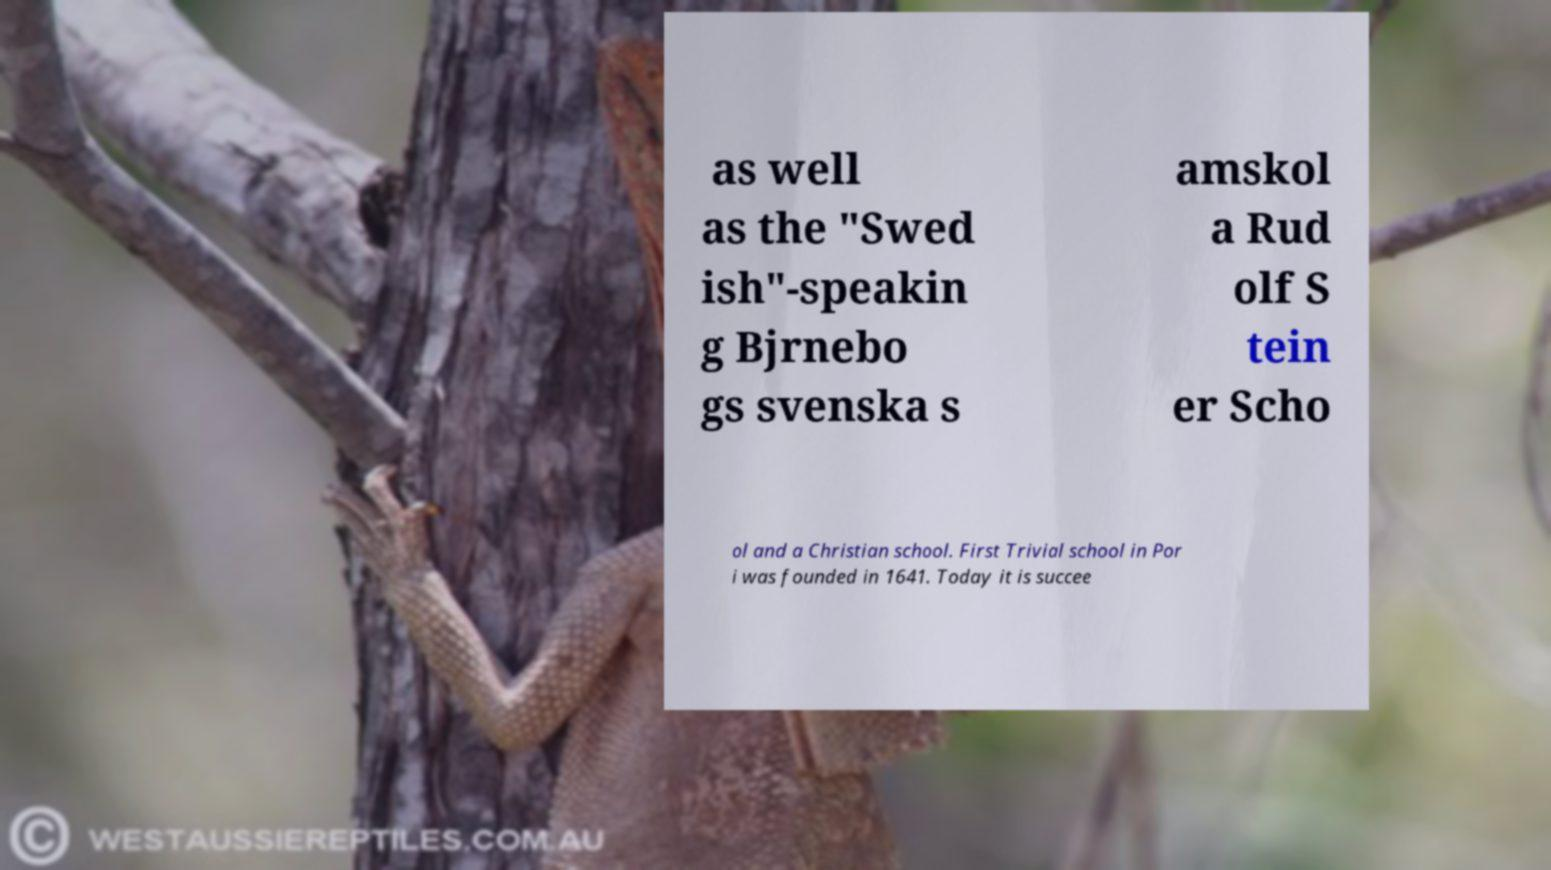For documentation purposes, I need the text within this image transcribed. Could you provide that? as well as the "Swed ish"-speakin g Bjrnebo gs svenska s amskol a Rud olf S tein er Scho ol and a Christian school. First Trivial school in Por i was founded in 1641. Today it is succee 